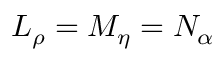<formula> <loc_0><loc_0><loc_500><loc_500>L _ { \rho } = M _ { \eta } = N _ { \alpha }</formula> 